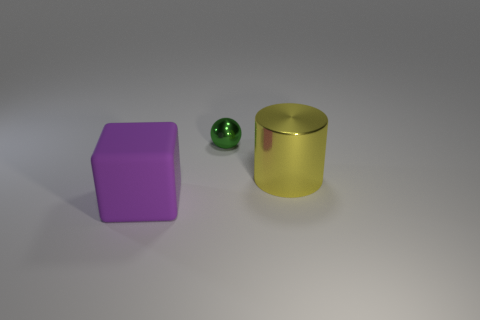How many things are either big things to the left of the big yellow cylinder or things that are behind the purple thing?
Your answer should be very brief. 3. Does the cylinder have the same color as the big thing left of the metal sphere?
Keep it short and to the point. No. There is a thing that is made of the same material as the sphere; what shape is it?
Offer a very short reply. Cylinder. How many rubber blocks are there?
Provide a short and direct response. 1. How many objects are things to the left of the cylinder or red cylinders?
Ensure brevity in your answer.  2. Does the object that is behind the yellow object have the same color as the big shiny thing?
Offer a very short reply. No. What number of small objects are matte blocks or yellow spheres?
Your answer should be compact. 0. Are there more large rubber blocks than tiny green matte things?
Provide a succinct answer. Yes. Does the big yellow cylinder have the same material as the large block?
Provide a short and direct response. No. Is there anything else that has the same material as the cylinder?
Your response must be concise. Yes. 